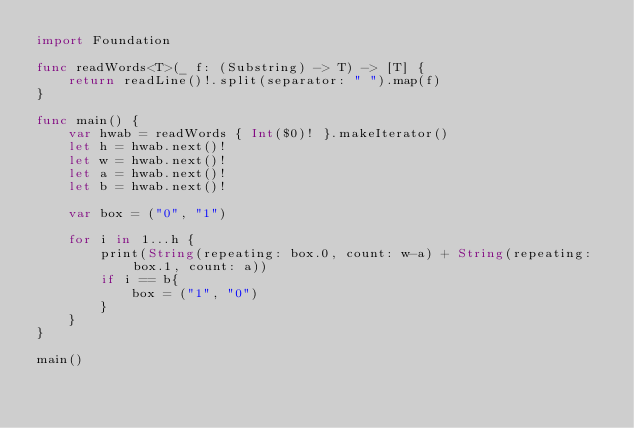<code> <loc_0><loc_0><loc_500><loc_500><_Swift_>import Foundation

func readWords<T>(_ f: (Substring) -> T) -> [T] {
    return readLine()!.split(separator: " ").map(f)
}

func main() {
    var hwab = readWords { Int($0)! }.makeIterator()
    let h = hwab.next()!
    let w = hwab.next()!
    let a = hwab.next()!
    let b = hwab.next()!

    var box = ("0", "1")

    for i in 1...h {
        print(String(repeating: box.0, count: w-a) + String(repeating: box.1, count: a))
        if i == b{
            box = ("1", "0")
        }
    }
}

main()</code> 